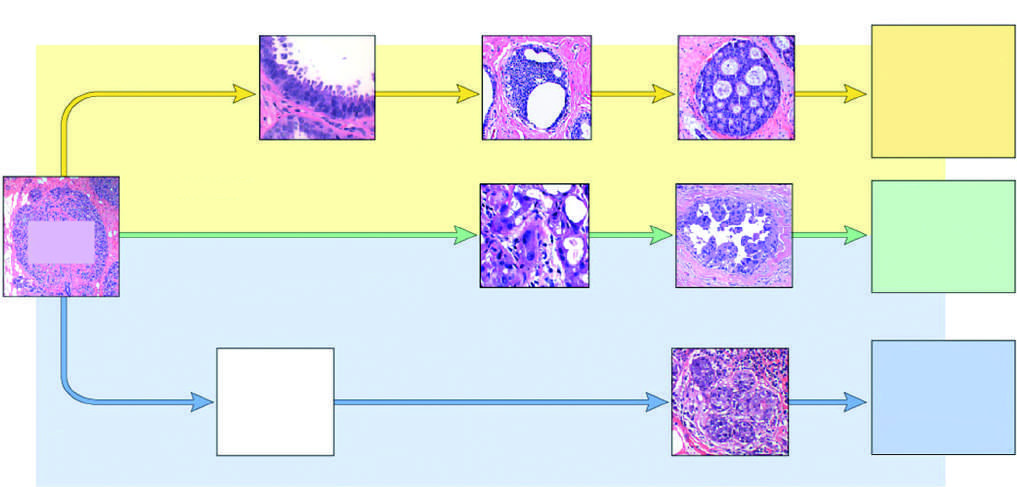s the head atypical apocrine adenosis, which shares features with apocrine dcis?
Answer the question using a single word or phrase. No 